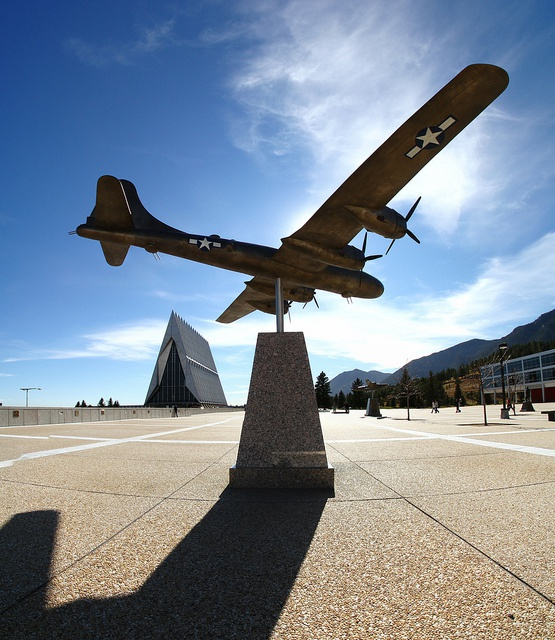Describe the objects in this image and their specific colors. I can see airplane in darkblue, black, white, and lightblue tones, people in darkblue, black, gray, and maroon tones, people in darkblue, black, gray, and lightgray tones, people in darkblue, black, and gray tones, and people in darkblue, black, gray, teal, and lightgray tones in this image. 